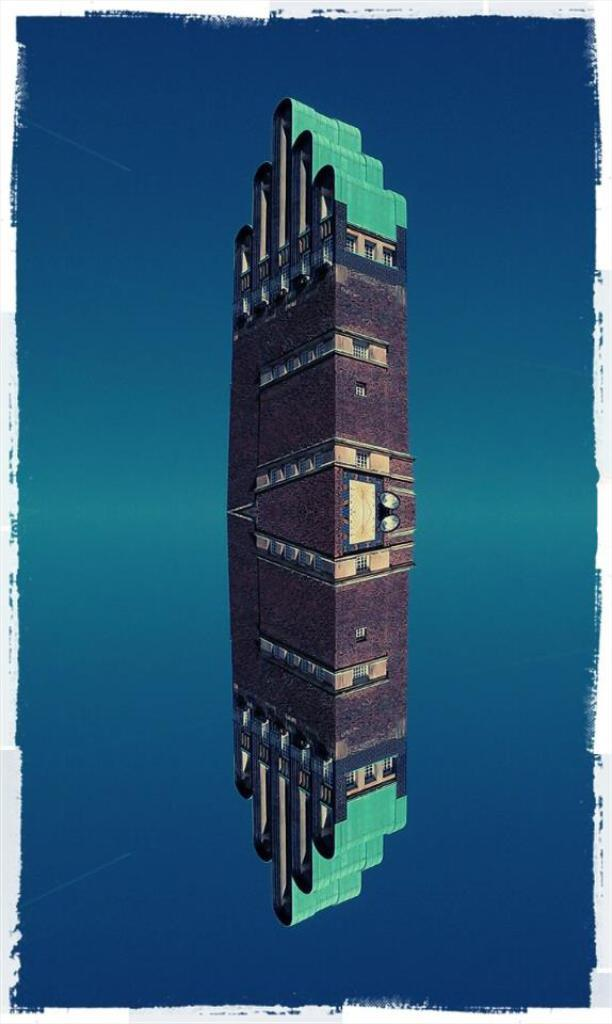What structure is the main subject of the image? There is a building in the image. What color is the background of the image? The background of the image is blue. How does the desire for bananas affect the monkey in the image? There is no monkey present in the image, and therefore no such desire or its effects can be observed. 